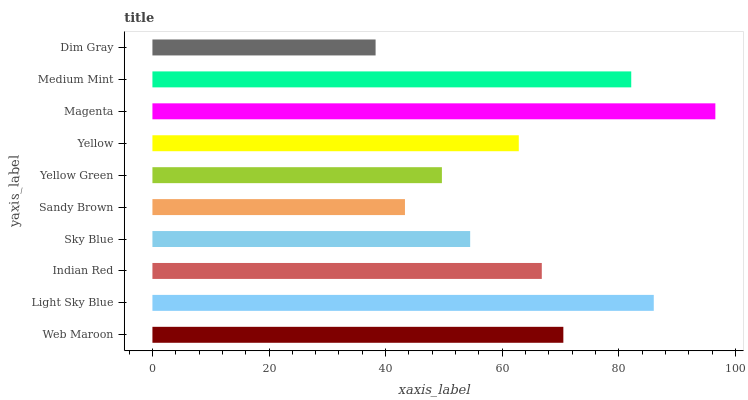Is Dim Gray the minimum?
Answer yes or no. Yes. Is Magenta the maximum?
Answer yes or no. Yes. Is Light Sky Blue the minimum?
Answer yes or no. No. Is Light Sky Blue the maximum?
Answer yes or no. No. Is Light Sky Blue greater than Web Maroon?
Answer yes or no. Yes. Is Web Maroon less than Light Sky Blue?
Answer yes or no. Yes. Is Web Maroon greater than Light Sky Blue?
Answer yes or no. No. Is Light Sky Blue less than Web Maroon?
Answer yes or no. No. Is Indian Red the high median?
Answer yes or no. Yes. Is Yellow the low median?
Answer yes or no. Yes. Is Sky Blue the high median?
Answer yes or no. No. Is Dim Gray the low median?
Answer yes or no. No. 